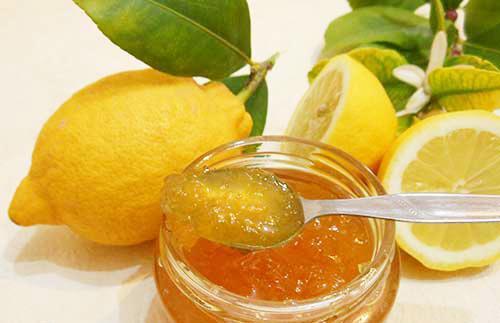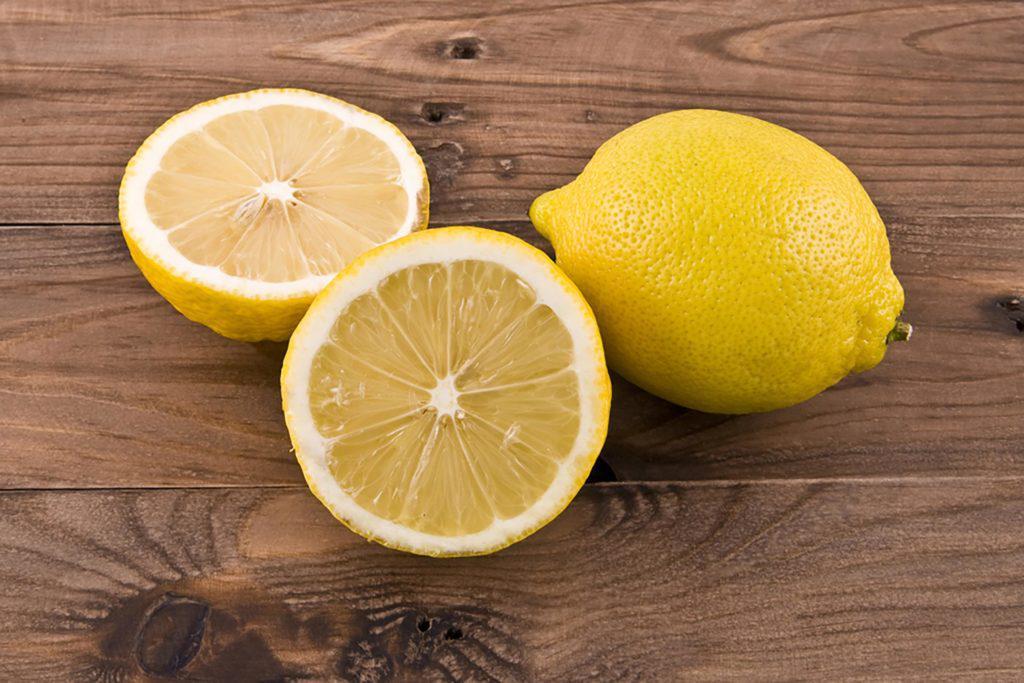The first image is the image on the left, the second image is the image on the right. Analyze the images presented: Is the assertion "The lemon slices are on top of meat in at least one of the images." valid? Answer yes or no. No. The first image is the image on the left, the second image is the image on the right. For the images shown, is this caption "There is a whole lemon in exactly one of the images." true? Answer yes or no. No. 